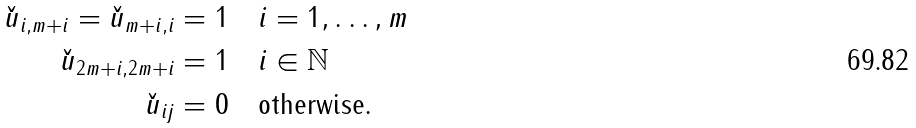<formula> <loc_0><loc_0><loc_500><loc_500>\check { u } _ { i , m + i } = \check { u } _ { m + i , i } = 1 & \quad i = 1 , \dots , m \\ \check { u } _ { 2 m + i , 2 m + i } = 1 & \quad i \in \mathbb { N } \\ \check { u } _ { i j } = 0 & \quad \text {otherwise} .</formula> 